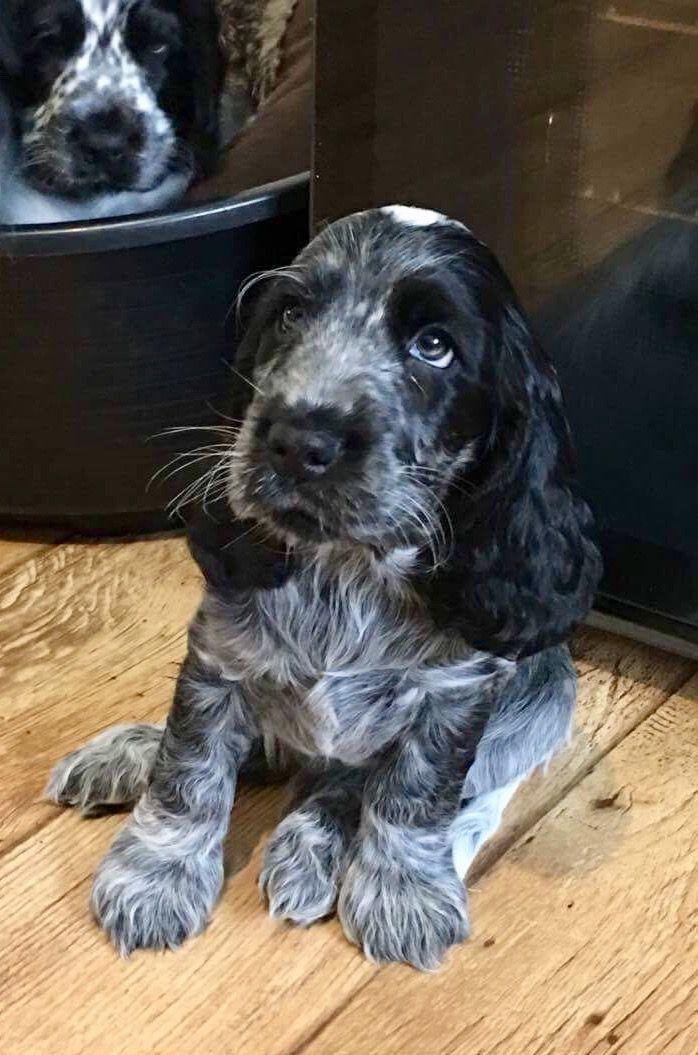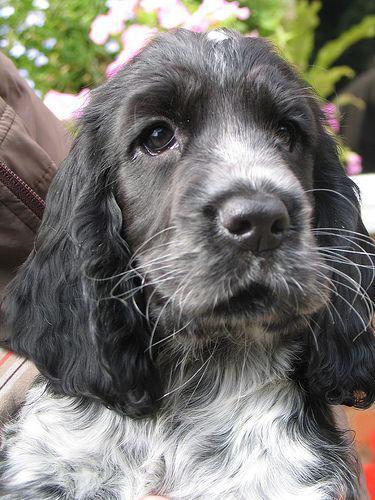The first image is the image on the left, the second image is the image on the right. Evaluate the accuracy of this statement regarding the images: "The pair of images includes two dogs held by human hands.". Is it true? Answer yes or no. No. 